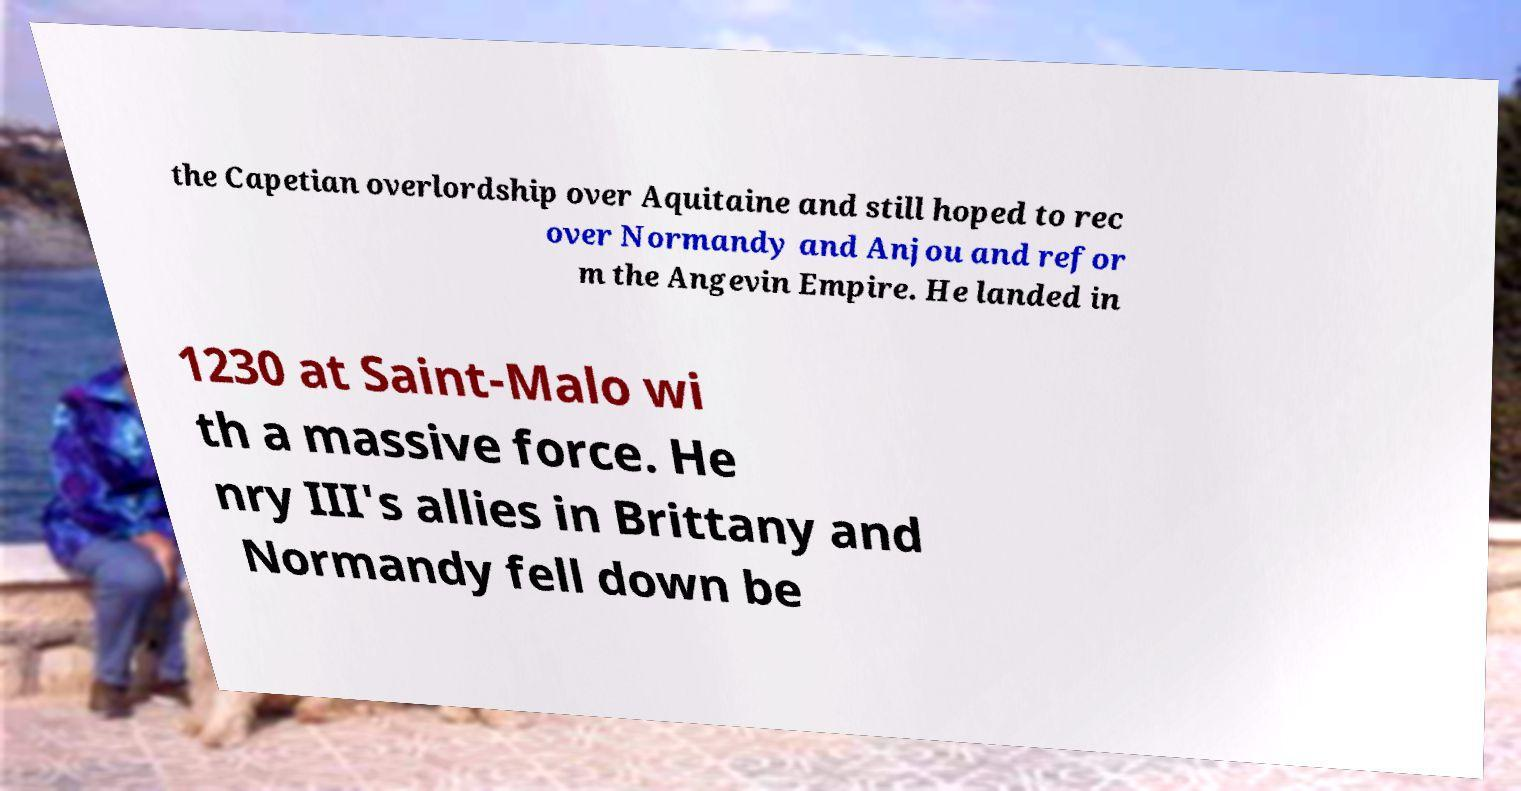There's text embedded in this image that I need extracted. Can you transcribe it verbatim? the Capetian overlordship over Aquitaine and still hoped to rec over Normandy and Anjou and refor m the Angevin Empire. He landed in 1230 at Saint-Malo wi th a massive force. He nry III's allies in Brittany and Normandy fell down be 